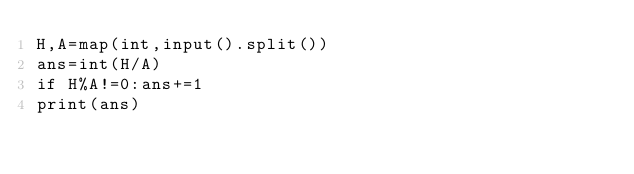Convert code to text. <code><loc_0><loc_0><loc_500><loc_500><_Python_>H,A=map(int,input().split())
ans=int(H/A)
if H%A!=0:ans+=1
print(ans)</code> 